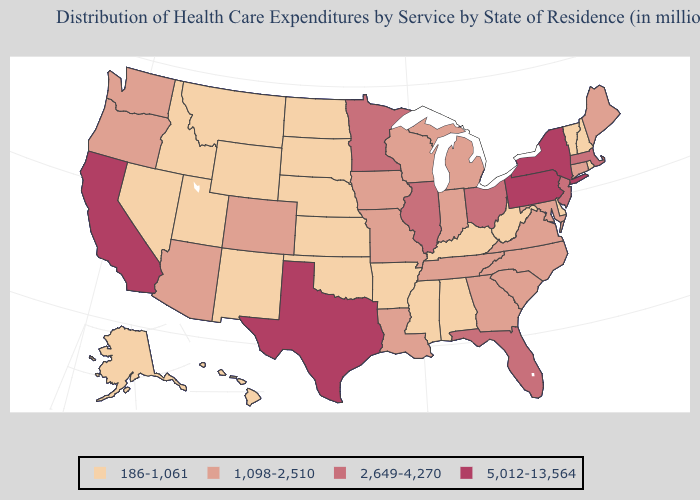Which states have the lowest value in the USA?
Short answer required. Alabama, Alaska, Arkansas, Delaware, Hawaii, Idaho, Kansas, Kentucky, Mississippi, Montana, Nebraska, Nevada, New Hampshire, New Mexico, North Dakota, Oklahoma, Rhode Island, South Dakota, Utah, Vermont, West Virginia, Wyoming. Among the states that border Virginia , which have the lowest value?
Give a very brief answer. Kentucky, West Virginia. Does New Mexico have the highest value in the USA?
Short answer required. No. Name the states that have a value in the range 2,649-4,270?
Be succinct. Florida, Illinois, Massachusetts, Minnesota, New Jersey, Ohio. Name the states that have a value in the range 186-1,061?
Be succinct. Alabama, Alaska, Arkansas, Delaware, Hawaii, Idaho, Kansas, Kentucky, Mississippi, Montana, Nebraska, Nevada, New Hampshire, New Mexico, North Dakota, Oklahoma, Rhode Island, South Dakota, Utah, Vermont, West Virginia, Wyoming. Name the states that have a value in the range 186-1,061?
Short answer required. Alabama, Alaska, Arkansas, Delaware, Hawaii, Idaho, Kansas, Kentucky, Mississippi, Montana, Nebraska, Nevada, New Hampshire, New Mexico, North Dakota, Oklahoma, Rhode Island, South Dakota, Utah, Vermont, West Virginia, Wyoming. What is the value of Georgia?
Keep it brief. 1,098-2,510. What is the value of Ohio?
Keep it brief. 2,649-4,270. Among the states that border Idaho , which have the highest value?
Quick response, please. Oregon, Washington. Name the states that have a value in the range 186-1,061?
Give a very brief answer. Alabama, Alaska, Arkansas, Delaware, Hawaii, Idaho, Kansas, Kentucky, Mississippi, Montana, Nebraska, Nevada, New Hampshire, New Mexico, North Dakota, Oklahoma, Rhode Island, South Dakota, Utah, Vermont, West Virginia, Wyoming. What is the value of Georgia?
Quick response, please. 1,098-2,510. What is the value of North Carolina?
Be succinct. 1,098-2,510. What is the highest value in the South ?
Quick response, please. 5,012-13,564. Does Oklahoma have the lowest value in the USA?
Write a very short answer. Yes. Name the states that have a value in the range 5,012-13,564?
Be succinct. California, New York, Pennsylvania, Texas. 